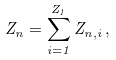Convert formula to latex. <formula><loc_0><loc_0><loc_500><loc_500>Z _ { n } = \sum _ { i = 1 } ^ { Z _ { 1 } } Z _ { n , i } \, ,</formula> 